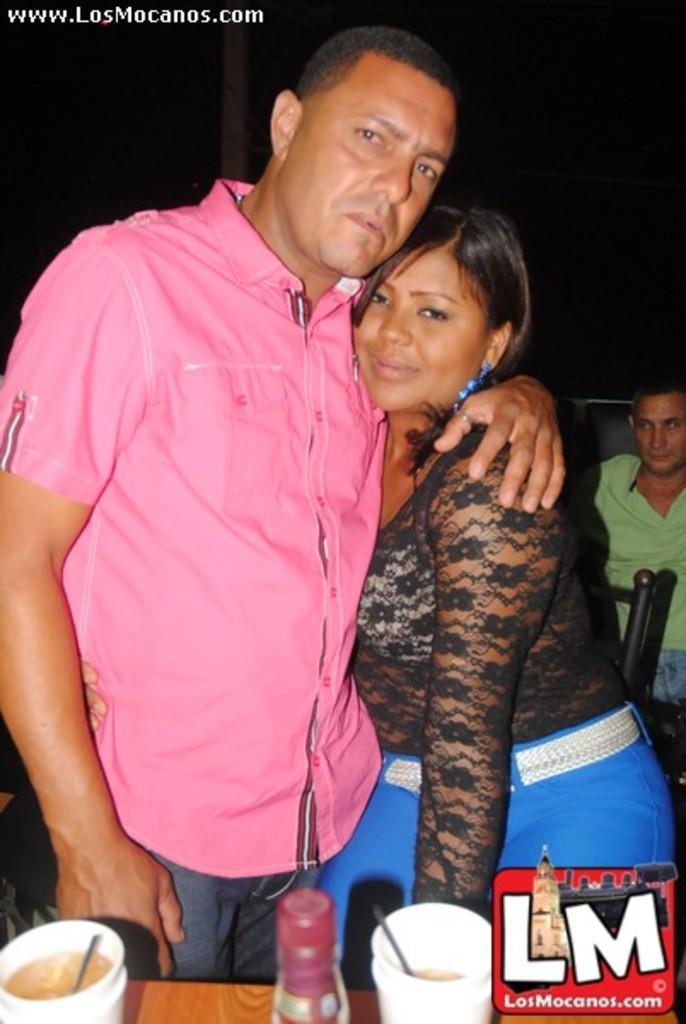Could you give a brief overview of what you see in this image? In this image there is a couple standing, behind the couple there is a person, in front of them there is a table with some glasses and bottle on it. At the bottom right side of the image there is a logo. At the top right side of the image there is some text. 